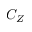<formula> <loc_0><loc_0><loc_500><loc_500>C _ { Z }</formula> 